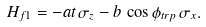<formula> <loc_0><loc_0><loc_500><loc_500>H _ { f 1 } = - a t \, \sigma _ { z } - b \, \cos \phi _ { t r p } \, \sigma _ { x } .</formula> 